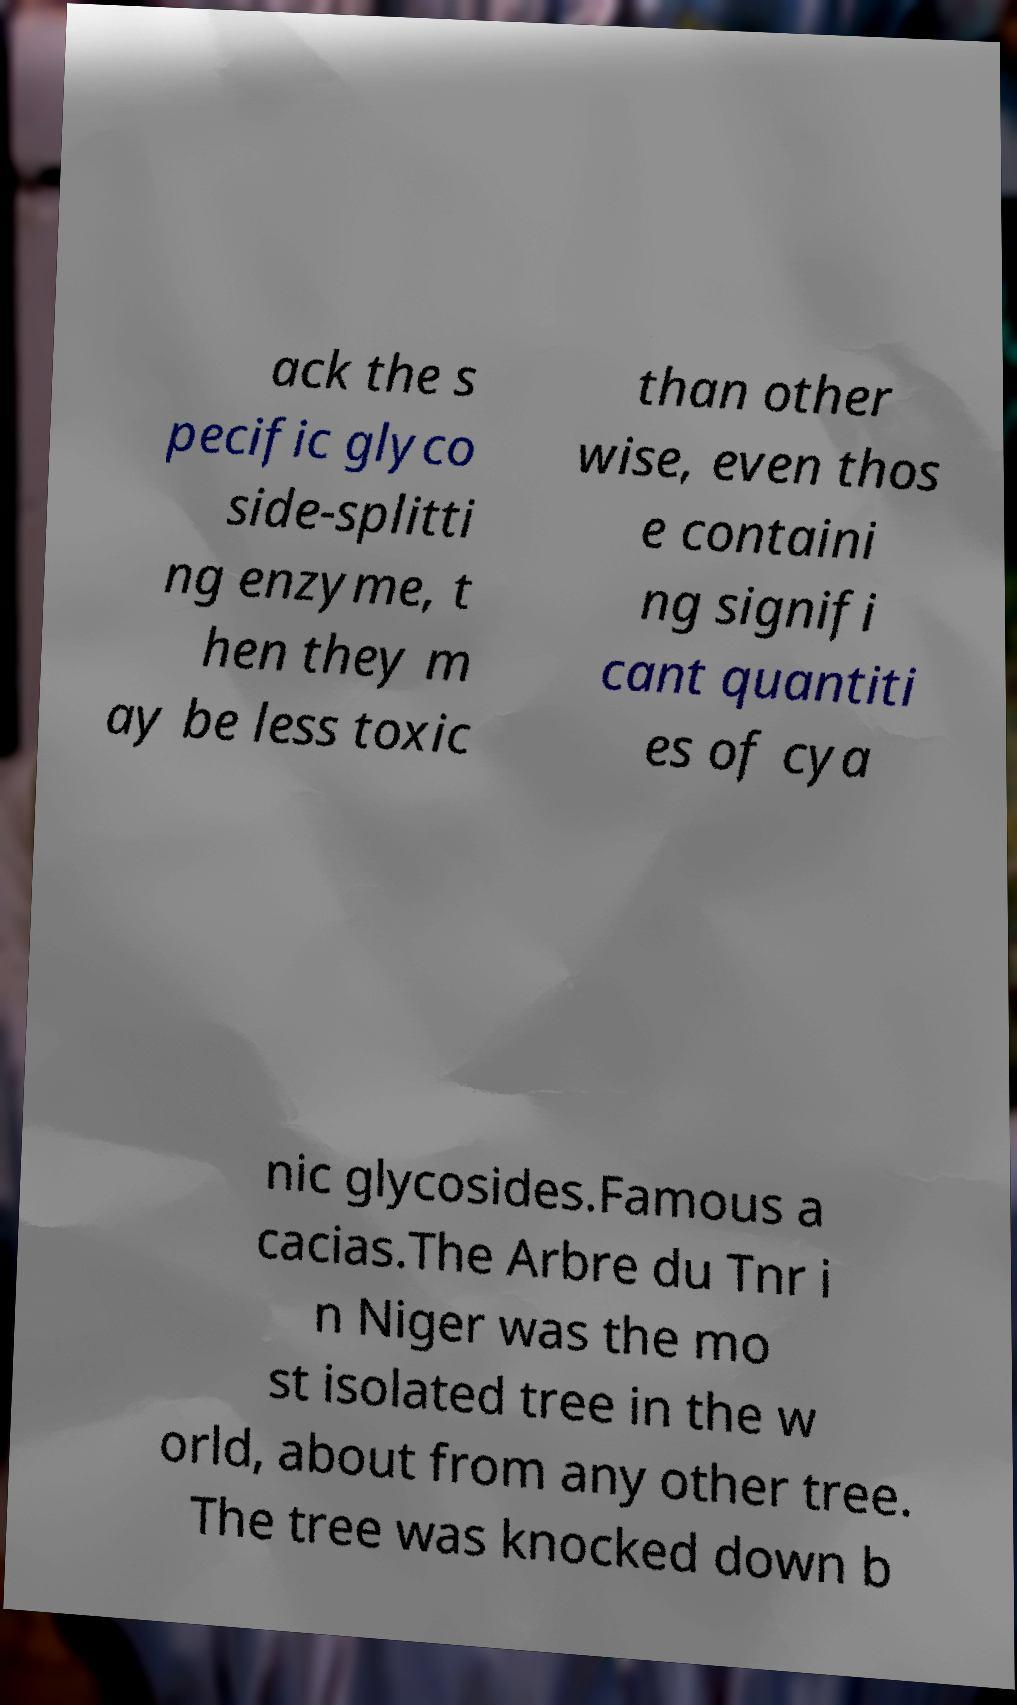There's text embedded in this image that I need extracted. Can you transcribe it verbatim? ack the s pecific glyco side-splitti ng enzyme, t hen they m ay be less toxic than other wise, even thos e containi ng signifi cant quantiti es of cya nic glycosides.Famous a cacias.The Arbre du Tnr i n Niger was the mo st isolated tree in the w orld, about from any other tree. The tree was knocked down b 